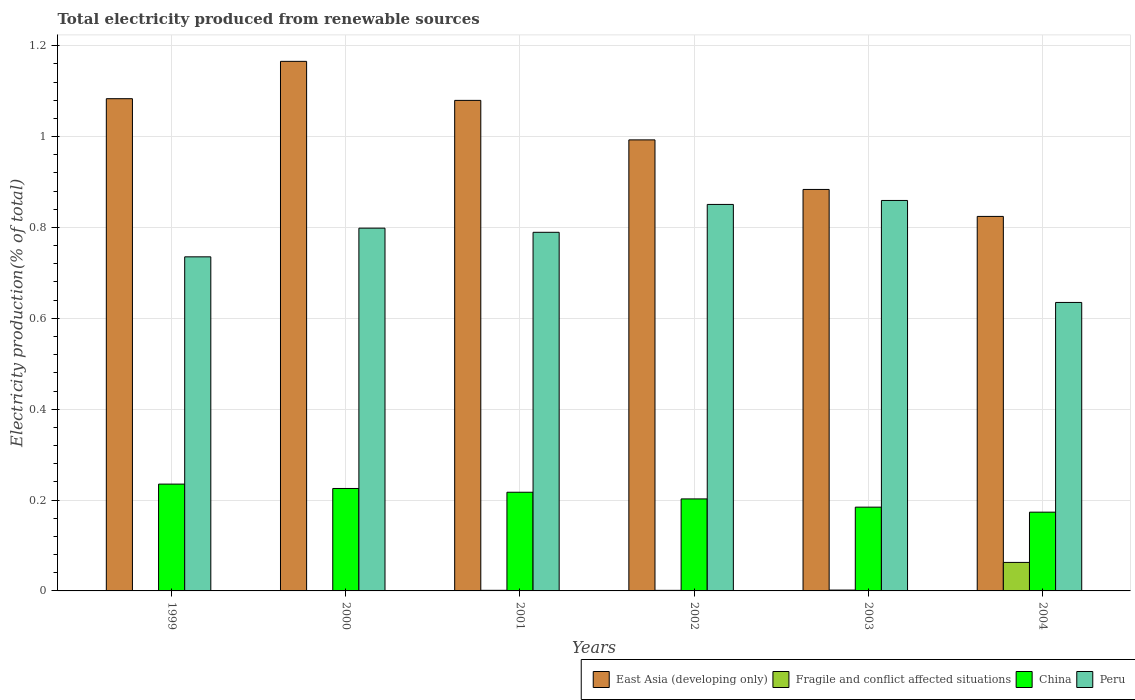Are the number of bars per tick equal to the number of legend labels?
Your response must be concise. Yes. Are the number of bars on each tick of the X-axis equal?
Your answer should be compact. Yes. How many bars are there on the 1st tick from the left?
Offer a terse response. 4. How many bars are there on the 1st tick from the right?
Provide a short and direct response. 4. What is the label of the 3rd group of bars from the left?
Make the answer very short. 2001. What is the total electricity produced in East Asia (developing only) in 1999?
Provide a succinct answer. 1.08. Across all years, what is the maximum total electricity produced in East Asia (developing only)?
Offer a very short reply. 1.17. Across all years, what is the minimum total electricity produced in Fragile and conflict affected situations?
Provide a short and direct response. 0. In which year was the total electricity produced in China maximum?
Your answer should be very brief. 1999. In which year was the total electricity produced in East Asia (developing only) minimum?
Make the answer very short. 2004. What is the total total electricity produced in East Asia (developing only) in the graph?
Your response must be concise. 6.03. What is the difference between the total electricity produced in Peru in 2000 and that in 2002?
Your response must be concise. -0.05. What is the difference between the total electricity produced in East Asia (developing only) in 2003 and the total electricity produced in Peru in 2004?
Your answer should be compact. 0.25. What is the average total electricity produced in Peru per year?
Your answer should be very brief. 0.78. In the year 2000, what is the difference between the total electricity produced in Peru and total electricity produced in East Asia (developing only)?
Your response must be concise. -0.37. What is the ratio of the total electricity produced in Peru in 2000 to that in 2003?
Make the answer very short. 0.93. What is the difference between the highest and the second highest total electricity produced in Peru?
Keep it short and to the point. 0.01. What is the difference between the highest and the lowest total electricity produced in China?
Your answer should be very brief. 0.06. Is it the case that in every year, the sum of the total electricity produced in Peru and total electricity produced in Fragile and conflict affected situations is greater than the sum of total electricity produced in China and total electricity produced in East Asia (developing only)?
Your answer should be compact. No. What does the 2nd bar from the left in 2004 represents?
Provide a short and direct response. Fragile and conflict affected situations. What does the 3rd bar from the right in 2002 represents?
Your response must be concise. Fragile and conflict affected situations. Is it the case that in every year, the sum of the total electricity produced in China and total electricity produced in East Asia (developing only) is greater than the total electricity produced in Peru?
Provide a succinct answer. Yes. How many bars are there?
Your answer should be compact. 24. How many years are there in the graph?
Ensure brevity in your answer.  6. What is the difference between two consecutive major ticks on the Y-axis?
Your answer should be compact. 0.2. Are the values on the major ticks of Y-axis written in scientific E-notation?
Keep it short and to the point. No. Does the graph contain any zero values?
Provide a short and direct response. No. Does the graph contain grids?
Your response must be concise. Yes. Where does the legend appear in the graph?
Offer a terse response. Bottom right. How many legend labels are there?
Offer a terse response. 4. What is the title of the graph?
Your answer should be very brief. Total electricity produced from renewable sources. What is the Electricity production(% of total) of East Asia (developing only) in 1999?
Offer a terse response. 1.08. What is the Electricity production(% of total) of Fragile and conflict affected situations in 1999?
Your response must be concise. 0. What is the Electricity production(% of total) of China in 1999?
Give a very brief answer. 0.24. What is the Electricity production(% of total) of Peru in 1999?
Offer a very short reply. 0.74. What is the Electricity production(% of total) of East Asia (developing only) in 2000?
Offer a very short reply. 1.17. What is the Electricity production(% of total) of Fragile and conflict affected situations in 2000?
Offer a terse response. 0. What is the Electricity production(% of total) of China in 2000?
Ensure brevity in your answer.  0.23. What is the Electricity production(% of total) of Peru in 2000?
Make the answer very short. 0.8. What is the Electricity production(% of total) in East Asia (developing only) in 2001?
Make the answer very short. 1.08. What is the Electricity production(% of total) in Fragile and conflict affected situations in 2001?
Provide a short and direct response. 0. What is the Electricity production(% of total) in China in 2001?
Make the answer very short. 0.22. What is the Electricity production(% of total) of Peru in 2001?
Provide a short and direct response. 0.79. What is the Electricity production(% of total) in East Asia (developing only) in 2002?
Make the answer very short. 0.99. What is the Electricity production(% of total) in Fragile and conflict affected situations in 2002?
Provide a short and direct response. 0. What is the Electricity production(% of total) in China in 2002?
Offer a very short reply. 0.2. What is the Electricity production(% of total) in Peru in 2002?
Your answer should be very brief. 0.85. What is the Electricity production(% of total) in East Asia (developing only) in 2003?
Offer a very short reply. 0.88. What is the Electricity production(% of total) of Fragile and conflict affected situations in 2003?
Provide a short and direct response. 0. What is the Electricity production(% of total) in China in 2003?
Provide a succinct answer. 0.18. What is the Electricity production(% of total) of Peru in 2003?
Offer a very short reply. 0.86. What is the Electricity production(% of total) of East Asia (developing only) in 2004?
Give a very brief answer. 0.82. What is the Electricity production(% of total) of Fragile and conflict affected situations in 2004?
Provide a short and direct response. 0.06. What is the Electricity production(% of total) in China in 2004?
Your answer should be compact. 0.17. What is the Electricity production(% of total) of Peru in 2004?
Your response must be concise. 0.63. Across all years, what is the maximum Electricity production(% of total) of East Asia (developing only)?
Your answer should be compact. 1.17. Across all years, what is the maximum Electricity production(% of total) of Fragile and conflict affected situations?
Keep it short and to the point. 0.06. Across all years, what is the maximum Electricity production(% of total) in China?
Give a very brief answer. 0.24. Across all years, what is the maximum Electricity production(% of total) of Peru?
Your answer should be compact. 0.86. Across all years, what is the minimum Electricity production(% of total) in East Asia (developing only)?
Make the answer very short. 0.82. Across all years, what is the minimum Electricity production(% of total) in Fragile and conflict affected situations?
Offer a terse response. 0. Across all years, what is the minimum Electricity production(% of total) in China?
Give a very brief answer. 0.17. Across all years, what is the minimum Electricity production(% of total) of Peru?
Provide a succinct answer. 0.63. What is the total Electricity production(% of total) in East Asia (developing only) in the graph?
Provide a short and direct response. 6.03. What is the total Electricity production(% of total) of Fragile and conflict affected situations in the graph?
Keep it short and to the point. 0.07. What is the total Electricity production(% of total) of China in the graph?
Provide a succinct answer. 1.24. What is the total Electricity production(% of total) of Peru in the graph?
Your answer should be compact. 4.67. What is the difference between the Electricity production(% of total) of East Asia (developing only) in 1999 and that in 2000?
Your answer should be compact. -0.08. What is the difference between the Electricity production(% of total) in Fragile and conflict affected situations in 1999 and that in 2000?
Your answer should be very brief. 0. What is the difference between the Electricity production(% of total) in China in 1999 and that in 2000?
Your answer should be compact. 0.01. What is the difference between the Electricity production(% of total) in Peru in 1999 and that in 2000?
Provide a short and direct response. -0.06. What is the difference between the Electricity production(% of total) of East Asia (developing only) in 1999 and that in 2001?
Make the answer very short. 0. What is the difference between the Electricity production(% of total) of Fragile and conflict affected situations in 1999 and that in 2001?
Your answer should be compact. -0. What is the difference between the Electricity production(% of total) of China in 1999 and that in 2001?
Keep it short and to the point. 0.02. What is the difference between the Electricity production(% of total) in Peru in 1999 and that in 2001?
Your response must be concise. -0.05. What is the difference between the Electricity production(% of total) in East Asia (developing only) in 1999 and that in 2002?
Give a very brief answer. 0.09. What is the difference between the Electricity production(% of total) of Fragile and conflict affected situations in 1999 and that in 2002?
Provide a succinct answer. -0. What is the difference between the Electricity production(% of total) of China in 1999 and that in 2002?
Provide a short and direct response. 0.03. What is the difference between the Electricity production(% of total) of Peru in 1999 and that in 2002?
Keep it short and to the point. -0.12. What is the difference between the Electricity production(% of total) of East Asia (developing only) in 1999 and that in 2003?
Your answer should be compact. 0.2. What is the difference between the Electricity production(% of total) of Fragile and conflict affected situations in 1999 and that in 2003?
Your answer should be very brief. -0. What is the difference between the Electricity production(% of total) of China in 1999 and that in 2003?
Keep it short and to the point. 0.05. What is the difference between the Electricity production(% of total) in Peru in 1999 and that in 2003?
Ensure brevity in your answer.  -0.12. What is the difference between the Electricity production(% of total) of East Asia (developing only) in 1999 and that in 2004?
Make the answer very short. 0.26. What is the difference between the Electricity production(% of total) in Fragile and conflict affected situations in 1999 and that in 2004?
Provide a short and direct response. -0.06. What is the difference between the Electricity production(% of total) of China in 1999 and that in 2004?
Keep it short and to the point. 0.06. What is the difference between the Electricity production(% of total) in Peru in 1999 and that in 2004?
Provide a short and direct response. 0.1. What is the difference between the Electricity production(% of total) in East Asia (developing only) in 2000 and that in 2001?
Offer a terse response. 0.09. What is the difference between the Electricity production(% of total) in Fragile and conflict affected situations in 2000 and that in 2001?
Provide a succinct answer. -0. What is the difference between the Electricity production(% of total) of China in 2000 and that in 2001?
Make the answer very short. 0.01. What is the difference between the Electricity production(% of total) of Peru in 2000 and that in 2001?
Give a very brief answer. 0.01. What is the difference between the Electricity production(% of total) of East Asia (developing only) in 2000 and that in 2002?
Offer a very short reply. 0.17. What is the difference between the Electricity production(% of total) in Fragile and conflict affected situations in 2000 and that in 2002?
Your response must be concise. -0. What is the difference between the Electricity production(% of total) of China in 2000 and that in 2002?
Offer a terse response. 0.02. What is the difference between the Electricity production(% of total) in Peru in 2000 and that in 2002?
Your answer should be compact. -0.05. What is the difference between the Electricity production(% of total) of East Asia (developing only) in 2000 and that in 2003?
Your answer should be very brief. 0.28. What is the difference between the Electricity production(% of total) of Fragile and conflict affected situations in 2000 and that in 2003?
Give a very brief answer. -0. What is the difference between the Electricity production(% of total) in China in 2000 and that in 2003?
Ensure brevity in your answer.  0.04. What is the difference between the Electricity production(% of total) in Peru in 2000 and that in 2003?
Your answer should be compact. -0.06. What is the difference between the Electricity production(% of total) in East Asia (developing only) in 2000 and that in 2004?
Ensure brevity in your answer.  0.34. What is the difference between the Electricity production(% of total) of Fragile and conflict affected situations in 2000 and that in 2004?
Provide a short and direct response. -0.06. What is the difference between the Electricity production(% of total) in China in 2000 and that in 2004?
Give a very brief answer. 0.05. What is the difference between the Electricity production(% of total) of Peru in 2000 and that in 2004?
Offer a very short reply. 0.16. What is the difference between the Electricity production(% of total) in East Asia (developing only) in 2001 and that in 2002?
Ensure brevity in your answer.  0.09. What is the difference between the Electricity production(% of total) of Fragile and conflict affected situations in 2001 and that in 2002?
Your answer should be compact. 0. What is the difference between the Electricity production(% of total) of China in 2001 and that in 2002?
Offer a terse response. 0.01. What is the difference between the Electricity production(% of total) of Peru in 2001 and that in 2002?
Provide a short and direct response. -0.06. What is the difference between the Electricity production(% of total) in East Asia (developing only) in 2001 and that in 2003?
Offer a very short reply. 0.2. What is the difference between the Electricity production(% of total) of Fragile and conflict affected situations in 2001 and that in 2003?
Your answer should be compact. -0. What is the difference between the Electricity production(% of total) of China in 2001 and that in 2003?
Keep it short and to the point. 0.03. What is the difference between the Electricity production(% of total) of Peru in 2001 and that in 2003?
Your answer should be compact. -0.07. What is the difference between the Electricity production(% of total) in East Asia (developing only) in 2001 and that in 2004?
Provide a succinct answer. 0.26. What is the difference between the Electricity production(% of total) in Fragile and conflict affected situations in 2001 and that in 2004?
Keep it short and to the point. -0.06. What is the difference between the Electricity production(% of total) in China in 2001 and that in 2004?
Offer a very short reply. 0.04. What is the difference between the Electricity production(% of total) in Peru in 2001 and that in 2004?
Ensure brevity in your answer.  0.15. What is the difference between the Electricity production(% of total) in East Asia (developing only) in 2002 and that in 2003?
Make the answer very short. 0.11. What is the difference between the Electricity production(% of total) in Fragile and conflict affected situations in 2002 and that in 2003?
Provide a succinct answer. -0. What is the difference between the Electricity production(% of total) in China in 2002 and that in 2003?
Provide a succinct answer. 0.02. What is the difference between the Electricity production(% of total) in Peru in 2002 and that in 2003?
Give a very brief answer. -0.01. What is the difference between the Electricity production(% of total) in East Asia (developing only) in 2002 and that in 2004?
Keep it short and to the point. 0.17. What is the difference between the Electricity production(% of total) of Fragile and conflict affected situations in 2002 and that in 2004?
Your answer should be very brief. -0.06. What is the difference between the Electricity production(% of total) of China in 2002 and that in 2004?
Give a very brief answer. 0.03. What is the difference between the Electricity production(% of total) of Peru in 2002 and that in 2004?
Offer a very short reply. 0.22. What is the difference between the Electricity production(% of total) of East Asia (developing only) in 2003 and that in 2004?
Provide a succinct answer. 0.06. What is the difference between the Electricity production(% of total) of Fragile and conflict affected situations in 2003 and that in 2004?
Offer a very short reply. -0.06. What is the difference between the Electricity production(% of total) of China in 2003 and that in 2004?
Give a very brief answer. 0.01. What is the difference between the Electricity production(% of total) of Peru in 2003 and that in 2004?
Provide a succinct answer. 0.22. What is the difference between the Electricity production(% of total) in East Asia (developing only) in 1999 and the Electricity production(% of total) in Fragile and conflict affected situations in 2000?
Provide a succinct answer. 1.08. What is the difference between the Electricity production(% of total) of East Asia (developing only) in 1999 and the Electricity production(% of total) of China in 2000?
Your answer should be compact. 0.86. What is the difference between the Electricity production(% of total) of East Asia (developing only) in 1999 and the Electricity production(% of total) of Peru in 2000?
Ensure brevity in your answer.  0.28. What is the difference between the Electricity production(% of total) in Fragile and conflict affected situations in 1999 and the Electricity production(% of total) in China in 2000?
Offer a terse response. -0.22. What is the difference between the Electricity production(% of total) of Fragile and conflict affected situations in 1999 and the Electricity production(% of total) of Peru in 2000?
Make the answer very short. -0.8. What is the difference between the Electricity production(% of total) of China in 1999 and the Electricity production(% of total) of Peru in 2000?
Make the answer very short. -0.56. What is the difference between the Electricity production(% of total) of East Asia (developing only) in 1999 and the Electricity production(% of total) of Fragile and conflict affected situations in 2001?
Provide a short and direct response. 1.08. What is the difference between the Electricity production(% of total) of East Asia (developing only) in 1999 and the Electricity production(% of total) of China in 2001?
Provide a succinct answer. 0.87. What is the difference between the Electricity production(% of total) in East Asia (developing only) in 1999 and the Electricity production(% of total) in Peru in 2001?
Give a very brief answer. 0.29. What is the difference between the Electricity production(% of total) in Fragile and conflict affected situations in 1999 and the Electricity production(% of total) in China in 2001?
Provide a short and direct response. -0.22. What is the difference between the Electricity production(% of total) in Fragile and conflict affected situations in 1999 and the Electricity production(% of total) in Peru in 2001?
Your answer should be compact. -0.79. What is the difference between the Electricity production(% of total) of China in 1999 and the Electricity production(% of total) of Peru in 2001?
Keep it short and to the point. -0.55. What is the difference between the Electricity production(% of total) in East Asia (developing only) in 1999 and the Electricity production(% of total) in Fragile and conflict affected situations in 2002?
Ensure brevity in your answer.  1.08. What is the difference between the Electricity production(% of total) of East Asia (developing only) in 1999 and the Electricity production(% of total) of China in 2002?
Make the answer very short. 0.88. What is the difference between the Electricity production(% of total) of East Asia (developing only) in 1999 and the Electricity production(% of total) of Peru in 2002?
Offer a terse response. 0.23. What is the difference between the Electricity production(% of total) in Fragile and conflict affected situations in 1999 and the Electricity production(% of total) in China in 2002?
Offer a terse response. -0.2. What is the difference between the Electricity production(% of total) of Fragile and conflict affected situations in 1999 and the Electricity production(% of total) of Peru in 2002?
Ensure brevity in your answer.  -0.85. What is the difference between the Electricity production(% of total) in China in 1999 and the Electricity production(% of total) in Peru in 2002?
Provide a succinct answer. -0.62. What is the difference between the Electricity production(% of total) of East Asia (developing only) in 1999 and the Electricity production(% of total) of Fragile and conflict affected situations in 2003?
Your answer should be compact. 1.08. What is the difference between the Electricity production(% of total) in East Asia (developing only) in 1999 and the Electricity production(% of total) in China in 2003?
Keep it short and to the point. 0.9. What is the difference between the Electricity production(% of total) of East Asia (developing only) in 1999 and the Electricity production(% of total) of Peru in 2003?
Give a very brief answer. 0.22. What is the difference between the Electricity production(% of total) of Fragile and conflict affected situations in 1999 and the Electricity production(% of total) of China in 2003?
Your response must be concise. -0.18. What is the difference between the Electricity production(% of total) of Fragile and conflict affected situations in 1999 and the Electricity production(% of total) of Peru in 2003?
Ensure brevity in your answer.  -0.86. What is the difference between the Electricity production(% of total) in China in 1999 and the Electricity production(% of total) in Peru in 2003?
Offer a terse response. -0.62. What is the difference between the Electricity production(% of total) in East Asia (developing only) in 1999 and the Electricity production(% of total) in Fragile and conflict affected situations in 2004?
Offer a terse response. 1.02. What is the difference between the Electricity production(% of total) in East Asia (developing only) in 1999 and the Electricity production(% of total) in China in 2004?
Your answer should be very brief. 0.91. What is the difference between the Electricity production(% of total) in East Asia (developing only) in 1999 and the Electricity production(% of total) in Peru in 2004?
Provide a succinct answer. 0.45. What is the difference between the Electricity production(% of total) in Fragile and conflict affected situations in 1999 and the Electricity production(% of total) in China in 2004?
Your answer should be very brief. -0.17. What is the difference between the Electricity production(% of total) of Fragile and conflict affected situations in 1999 and the Electricity production(% of total) of Peru in 2004?
Make the answer very short. -0.63. What is the difference between the Electricity production(% of total) of China in 1999 and the Electricity production(% of total) of Peru in 2004?
Offer a terse response. -0.4. What is the difference between the Electricity production(% of total) of East Asia (developing only) in 2000 and the Electricity production(% of total) of Fragile and conflict affected situations in 2001?
Provide a succinct answer. 1.16. What is the difference between the Electricity production(% of total) in East Asia (developing only) in 2000 and the Electricity production(% of total) in China in 2001?
Offer a very short reply. 0.95. What is the difference between the Electricity production(% of total) in East Asia (developing only) in 2000 and the Electricity production(% of total) in Peru in 2001?
Provide a succinct answer. 0.38. What is the difference between the Electricity production(% of total) of Fragile and conflict affected situations in 2000 and the Electricity production(% of total) of China in 2001?
Keep it short and to the point. -0.22. What is the difference between the Electricity production(% of total) of Fragile and conflict affected situations in 2000 and the Electricity production(% of total) of Peru in 2001?
Provide a succinct answer. -0.79. What is the difference between the Electricity production(% of total) of China in 2000 and the Electricity production(% of total) of Peru in 2001?
Your answer should be very brief. -0.56. What is the difference between the Electricity production(% of total) in East Asia (developing only) in 2000 and the Electricity production(% of total) in Fragile and conflict affected situations in 2002?
Offer a terse response. 1.16. What is the difference between the Electricity production(% of total) of East Asia (developing only) in 2000 and the Electricity production(% of total) of China in 2002?
Provide a short and direct response. 0.96. What is the difference between the Electricity production(% of total) of East Asia (developing only) in 2000 and the Electricity production(% of total) of Peru in 2002?
Your answer should be compact. 0.31. What is the difference between the Electricity production(% of total) of Fragile and conflict affected situations in 2000 and the Electricity production(% of total) of China in 2002?
Your answer should be compact. -0.2. What is the difference between the Electricity production(% of total) of Fragile and conflict affected situations in 2000 and the Electricity production(% of total) of Peru in 2002?
Provide a short and direct response. -0.85. What is the difference between the Electricity production(% of total) of China in 2000 and the Electricity production(% of total) of Peru in 2002?
Offer a very short reply. -0.63. What is the difference between the Electricity production(% of total) in East Asia (developing only) in 2000 and the Electricity production(% of total) in Fragile and conflict affected situations in 2003?
Make the answer very short. 1.16. What is the difference between the Electricity production(% of total) of East Asia (developing only) in 2000 and the Electricity production(% of total) of China in 2003?
Offer a terse response. 0.98. What is the difference between the Electricity production(% of total) in East Asia (developing only) in 2000 and the Electricity production(% of total) in Peru in 2003?
Give a very brief answer. 0.31. What is the difference between the Electricity production(% of total) of Fragile and conflict affected situations in 2000 and the Electricity production(% of total) of China in 2003?
Ensure brevity in your answer.  -0.18. What is the difference between the Electricity production(% of total) in Fragile and conflict affected situations in 2000 and the Electricity production(% of total) in Peru in 2003?
Make the answer very short. -0.86. What is the difference between the Electricity production(% of total) in China in 2000 and the Electricity production(% of total) in Peru in 2003?
Ensure brevity in your answer.  -0.63. What is the difference between the Electricity production(% of total) in East Asia (developing only) in 2000 and the Electricity production(% of total) in Fragile and conflict affected situations in 2004?
Offer a terse response. 1.1. What is the difference between the Electricity production(% of total) in East Asia (developing only) in 2000 and the Electricity production(% of total) in Peru in 2004?
Ensure brevity in your answer.  0.53. What is the difference between the Electricity production(% of total) of Fragile and conflict affected situations in 2000 and the Electricity production(% of total) of China in 2004?
Make the answer very short. -0.17. What is the difference between the Electricity production(% of total) in Fragile and conflict affected situations in 2000 and the Electricity production(% of total) in Peru in 2004?
Offer a terse response. -0.63. What is the difference between the Electricity production(% of total) of China in 2000 and the Electricity production(% of total) of Peru in 2004?
Offer a very short reply. -0.41. What is the difference between the Electricity production(% of total) in East Asia (developing only) in 2001 and the Electricity production(% of total) in Fragile and conflict affected situations in 2002?
Your answer should be compact. 1.08. What is the difference between the Electricity production(% of total) in East Asia (developing only) in 2001 and the Electricity production(% of total) in China in 2002?
Your answer should be very brief. 0.88. What is the difference between the Electricity production(% of total) in East Asia (developing only) in 2001 and the Electricity production(% of total) in Peru in 2002?
Your answer should be compact. 0.23. What is the difference between the Electricity production(% of total) of Fragile and conflict affected situations in 2001 and the Electricity production(% of total) of China in 2002?
Your response must be concise. -0.2. What is the difference between the Electricity production(% of total) in Fragile and conflict affected situations in 2001 and the Electricity production(% of total) in Peru in 2002?
Ensure brevity in your answer.  -0.85. What is the difference between the Electricity production(% of total) of China in 2001 and the Electricity production(% of total) of Peru in 2002?
Provide a short and direct response. -0.63. What is the difference between the Electricity production(% of total) in East Asia (developing only) in 2001 and the Electricity production(% of total) in Fragile and conflict affected situations in 2003?
Ensure brevity in your answer.  1.08. What is the difference between the Electricity production(% of total) of East Asia (developing only) in 2001 and the Electricity production(% of total) of China in 2003?
Make the answer very short. 0.9. What is the difference between the Electricity production(% of total) in East Asia (developing only) in 2001 and the Electricity production(% of total) in Peru in 2003?
Give a very brief answer. 0.22. What is the difference between the Electricity production(% of total) in Fragile and conflict affected situations in 2001 and the Electricity production(% of total) in China in 2003?
Your answer should be very brief. -0.18. What is the difference between the Electricity production(% of total) in Fragile and conflict affected situations in 2001 and the Electricity production(% of total) in Peru in 2003?
Make the answer very short. -0.86. What is the difference between the Electricity production(% of total) of China in 2001 and the Electricity production(% of total) of Peru in 2003?
Give a very brief answer. -0.64. What is the difference between the Electricity production(% of total) in East Asia (developing only) in 2001 and the Electricity production(% of total) in Fragile and conflict affected situations in 2004?
Offer a terse response. 1.02. What is the difference between the Electricity production(% of total) of East Asia (developing only) in 2001 and the Electricity production(% of total) of China in 2004?
Give a very brief answer. 0.91. What is the difference between the Electricity production(% of total) of East Asia (developing only) in 2001 and the Electricity production(% of total) of Peru in 2004?
Give a very brief answer. 0.44. What is the difference between the Electricity production(% of total) in Fragile and conflict affected situations in 2001 and the Electricity production(% of total) in China in 2004?
Provide a succinct answer. -0.17. What is the difference between the Electricity production(% of total) in Fragile and conflict affected situations in 2001 and the Electricity production(% of total) in Peru in 2004?
Offer a very short reply. -0.63. What is the difference between the Electricity production(% of total) in China in 2001 and the Electricity production(% of total) in Peru in 2004?
Offer a very short reply. -0.42. What is the difference between the Electricity production(% of total) of East Asia (developing only) in 2002 and the Electricity production(% of total) of China in 2003?
Offer a terse response. 0.81. What is the difference between the Electricity production(% of total) of East Asia (developing only) in 2002 and the Electricity production(% of total) of Peru in 2003?
Your answer should be compact. 0.13. What is the difference between the Electricity production(% of total) of Fragile and conflict affected situations in 2002 and the Electricity production(% of total) of China in 2003?
Offer a very short reply. -0.18. What is the difference between the Electricity production(% of total) in Fragile and conflict affected situations in 2002 and the Electricity production(% of total) in Peru in 2003?
Provide a succinct answer. -0.86. What is the difference between the Electricity production(% of total) in China in 2002 and the Electricity production(% of total) in Peru in 2003?
Provide a succinct answer. -0.66. What is the difference between the Electricity production(% of total) in East Asia (developing only) in 2002 and the Electricity production(% of total) in Fragile and conflict affected situations in 2004?
Your answer should be very brief. 0.93. What is the difference between the Electricity production(% of total) of East Asia (developing only) in 2002 and the Electricity production(% of total) of China in 2004?
Ensure brevity in your answer.  0.82. What is the difference between the Electricity production(% of total) in East Asia (developing only) in 2002 and the Electricity production(% of total) in Peru in 2004?
Give a very brief answer. 0.36. What is the difference between the Electricity production(% of total) in Fragile and conflict affected situations in 2002 and the Electricity production(% of total) in China in 2004?
Keep it short and to the point. -0.17. What is the difference between the Electricity production(% of total) of Fragile and conflict affected situations in 2002 and the Electricity production(% of total) of Peru in 2004?
Offer a very short reply. -0.63. What is the difference between the Electricity production(% of total) of China in 2002 and the Electricity production(% of total) of Peru in 2004?
Offer a very short reply. -0.43. What is the difference between the Electricity production(% of total) in East Asia (developing only) in 2003 and the Electricity production(% of total) in Fragile and conflict affected situations in 2004?
Provide a succinct answer. 0.82. What is the difference between the Electricity production(% of total) in East Asia (developing only) in 2003 and the Electricity production(% of total) in China in 2004?
Offer a very short reply. 0.71. What is the difference between the Electricity production(% of total) in East Asia (developing only) in 2003 and the Electricity production(% of total) in Peru in 2004?
Ensure brevity in your answer.  0.25. What is the difference between the Electricity production(% of total) in Fragile and conflict affected situations in 2003 and the Electricity production(% of total) in China in 2004?
Keep it short and to the point. -0.17. What is the difference between the Electricity production(% of total) in Fragile and conflict affected situations in 2003 and the Electricity production(% of total) in Peru in 2004?
Offer a very short reply. -0.63. What is the difference between the Electricity production(% of total) in China in 2003 and the Electricity production(% of total) in Peru in 2004?
Offer a very short reply. -0.45. What is the average Electricity production(% of total) in East Asia (developing only) per year?
Provide a succinct answer. 1. What is the average Electricity production(% of total) of Fragile and conflict affected situations per year?
Offer a terse response. 0.01. What is the average Electricity production(% of total) in China per year?
Your answer should be compact. 0.21. What is the average Electricity production(% of total) in Peru per year?
Your answer should be compact. 0.78. In the year 1999, what is the difference between the Electricity production(% of total) of East Asia (developing only) and Electricity production(% of total) of Fragile and conflict affected situations?
Provide a succinct answer. 1.08. In the year 1999, what is the difference between the Electricity production(% of total) in East Asia (developing only) and Electricity production(% of total) in China?
Your response must be concise. 0.85. In the year 1999, what is the difference between the Electricity production(% of total) in East Asia (developing only) and Electricity production(% of total) in Peru?
Offer a very short reply. 0.35. In the year 1999, what is the difference between the Electricity production(% of total) of Fragile and conflict affected situations and Electricity production(% of total) of China?
Make the answer very short. -0.23. In the year 1999, what is the difference between the Electricity production(% of total) in Fragile and conflict affected situations and Electricity production(% of total) in Peru?
Keep it short and to the point. -0.73. In the year 1999, what is the difference between the Electricity production(% of total) in China and Electricity production(% of total) in Peru?
Provide a succinct answer. -0.5. In the year 2000, what is the difference between the Electricity production(% of total) in East Asia (developing only) and Electricity production(% of total) in Fragile and conflict affected situations?
Make the answer very short. 1.16. In the year 2000, what is the difference between the Electricity production(% of total) in East Asia (developing only) and Electricity production(% of total) in China?
Offer a terse response. 0.94. In the year 2000, what is the difference between the Electricity production(% of total) of East Asia (developing only) and Electricity production(% of total) of Peru?
Offer a very short reply. 0.37. In the year 2000, what is the difference between the Electricity production(% of total) in Fragile and conflict affected situations and Electricity production(% of total) in China?
Your answer should be very brief. -0.22. In the year 2000, what is the difference between the Electricity production(% of total) in Fragile and conflict affected situations and Electricity production(% of total) in Peru?
Make the answer very short. -0.8. In the year 2000, what is the difference between the Electricity production(% of total) in China and Electricity production(% of total) in Peru?
Your answer should be very brief. -0.57. In the year 2001, what is the difference between the Electricity production(% of total) of East Asia (developing only) and Electricity production(% of total) of Fragile and conflict affected situations?
Keep it short and to the point. 1.08. In the year 2001, what is the difference between the Electricity production(% of total) of East Asia (developing only) and Electricity production(% of total) of China?
Provide a short and direct response. 0.86. In the year 2001, what is the difference between the Electricity production(% of total) of East Asia (developing only) and Electricity production(% of total) of Peru?
Offer a very short reply. 0.29. In the year 2001, what is the difference between the Electricity production(% of total) of Fragile and conflict affected situations and Electricity production(% of total) of China?
Give a very brief answer. -0.22. In the year 2001, what is the difference between the Electricity production(% of total) in Fragile and conflict affected situations and Electricity production(% of total) in Peru?
Provide a short and direct response. -0.79. In the year 2001, what is the difference between the Electricity production(% of total) in China and Electricity production(% of total) in Peru?
Provide a succinct answer. -0.57. In the year 2002, what is the difference between the Electricity production(% of total) in East Asia (developing only) and Electricity production(% of total) in China?
Provide a succinct answer. 0.79. In the year 2002, what is the difference between the Electricity production(% of total) of East Asia (developing only) and Electricity production(% of total) of Peru?
Your answer should be compact. 0.14. In the year 2002, what is the difference between the Electricity production(% of total) of Fragile and conflict affected situations and Electricity production(% of total) of China?
Make the answer very short. -0.2. In the year 2002, what is the difference between the Electricity production(% of total) of Fragile and conflict affected situations and Electricity production(% of total) of Peru?
Offer a terse response. -0.85. In the year 2002, what is the difference between the Electricity production(% of total) of China and Electricity production(% of total) of Peru?
Keep it short and to the point. -0.65. In the year 2003, what is the difference between the Electricity production(% of total) of East Asia (developing only) and Electricity production(% of total) of Fragile and conflict affected situations?
Provide a succinct answer. 0.88. In the year 2003, what is the difference between the Electricity production(% of total) of East Asia (developing only) and Electricity production(% of total) of China?
Your response must be concise. 0.7. In the year 2003, what is the difference between the Electricity production(% of total) in East Asia (developing only) and Electricity production(% of total) in Peru?
Your answer should be very brief. 0.02. In the year 2003, what is the difference between the Electricity production(% of total) in Fragile and conflict affected situations and Electricity production(% of total) in China?
Offer a very short reply. -0.18. In the year 2003, what is the difference between the Electricity production(% of total) of Fragile and conflict affected situations and Electricity production(% of total) of Peru?
Provide a succinct answer. -0.86. In the year 2003, what is the difference between the Electricity production(% of total) in China and Electricity production(% of total) in Peru?
Your answer should be very brief. -0.68. In the year 2004, what is the difference between the Electricity production(% of total) in East Asia (developing only) and Electricity production(% of total) in Fragile and conflict affected situations?
Your answer should be compact. 0.76. In the year 2004, what is the difference between the Electricity production(% of total) of East Asia (developing only) and Electricity production(% of total) of China?
Give a very brief answer. 0.65. In the year 2004, what is the difference between the Electricity production(% of total) in East Asia (developing only) and Electricity production(% of total) in Peru?
Your answer should be very brief. 0.19. In the year 2004, what is the difference between the Electricity production(% of total) in Fragile and conflict affected situations and Electricity production(% of total) in China?
Your response must be concise. -0.11. In the year 2004, what is the difference between the Electricity production(% of total) in Fragile and conflict affected situations and Electricity production(% of total) in Peru?
Offer a very short reply. -0.57. In the year 2004, what is the difference between the Electricity production(% of total) in China and Electricity production(% of total) in Peru?
Offer a terse response. -0.46. What is the ratio of the Electricity production(% of total) in East Asia (developing only) in 1999 to that in 2000?
Make the answer very short. 0.93. What is the ratio of the Electricity production(% of total) in Fragile and conflict affected situations in 1999 to that in 2000?
Your answer should be compact. 1.04. What is the ratio of the Electricity production(% of total) of China in 1999 to that in 2000?
Offer a very short reply. 1.04. What is the ratio of the Electricity production(% of total) of Peru in 1999 to that in 2000?
Make the answer very short. 0.92. What is the ratio of the Electricity production(% of total) of East Asia (developing only) in 1999 to that in 2001?
Provide a succinct answer. 1. What is the ratio of the Electricity production(% of total) in Fragile and conflict affected situations in 1999 to that in 2001?
Give a very brief answer. 0.54. What is the ratio of the Electricity production(% of total) of China in 1999 to that in 2001?
Give a very brief answer. 1.08. What is the ratio of the Electricity production(% of total) of Peru in 1999 to that in 2001?
Offer a terse response. 0.93. What is the ratio of the Electricity production(% of total) in East Asia (developing only) in 1999 to that in 2002?
Your response must be concise. 1.09. What is the ratio of the Electricity production(% of total) in Fragile and conflict affected situations in 1999 to that in 2002?
Offer a very short reply. 0.58. What is the ratio of the Electricity production(% of total) in China in 1999 to that in 2002?
Keep it short and to the point. 1.16. What is the ratio of the Electricity production(% of total) in Peru in 1999 to that in 2002?
Your answer should be compact. 0.86. What is the ratio of the Electricity production(% of total) in East Asia (developing only) in 1999 to that in 2003?
Offer a very short reply. 1.23. What is the ratio of the Electricity production(% of total) in Fragile and conflict affected situations in 1999 to that in 2003?
Offer a terse response. 0.38. What is the ratio of the Electricity production(% of total) of China in 1999 to that in 2003?
Provide a succinct answer. 1.28. What is the ratio of the Electricity production(% of total) of Peru in 1999 to that in 2003?
Provide a short and direct response. 0.86. What is the ratio of the Electricity production(% of total) of East Asia (developing only) in 1999 to that in 2004?
Offer a terse response. 1.31. What is the ratio of the Electricity production(% of total) of Fragile and conflict affected situations in 1999 to that in 2004?
Provide a succinct answer. 0.01. What is the ratio of the Electricity production(% of total) in China in 1999 to that in 2004?
Your answer should be very brief. 1.36. What is the ratio of the Electricity production(% of total) in Peru in 1999 to that in 2004?
Your response must be concise. 1.16. What is the ratio of the Electricity production(% of total) in East Asia (developing only) in 2000 to that in 2001?
Your response must be concise. 1.08. What is the ratio of the Electricity production(% of total) in Fragile and conflict affected situations in 2000 to that in 2001?
Provide a succinct answer. 0.52. What is the ratio of the Electricity production(% of total) of China in 2000 to that in 2001?
Give a very brief answer. 1.04. What is the ratio of the Electricity production(% of total) in Peru in 2000 to that in 2001?
Your response must be concise. 1.01. What is the ratio of the Electricity production(% of total) of East Asia (developing only) in 2000 to that in 2002?
Offer a very short reply. 1.17. What is the ratio of the Electricity production(% of total) of Fragile and conflict affected situations in 2000 to that in 2002?
Give a very brief answer. 0.55. What is the ratio of the Electricity production(% of total) of China in 2000 to that in 2002?
Provide a succinct answer. 1.11. What is the ratio of the Electricity production(% of total) of Peru in 2000 to that in 2002?
Your answer should be compact. 0.94. What is the ratio of the Electricity production(% of total) of East Asia (developing only) in 2000 to that in 2003?
Give a very brief answer. 1.32. What is the ratio of the Electricity production(% of total) of Fragile and conflict affected situations in 2000 to that in 2003?
Offer a terse response. 0.37. What is the ratio of the Electricity production(% of total) in China in 2000 to that in 2003?
Keep it short and to the point. 1.22. What is the ratio of the Electricity production(% of total) in Peru in 2000 to that in 2003?
Your answer should be compact. 0.93. What is the ratio of the Electricity production(% of total) in East Asia (developing only) in 2000 to that in 2004?
Your answer should be compact. 1.41. What is the ratio of the Electricity production(% of total) in Fragile and conflict affected situations in 2000 to that in 2004?
Your answer should be compact. 0.01. What is the ratio of the Electricity production(% of total) in China in 2000 to that in 2004?
Provide a succinct answer. 1.3. What is the ratio of the Electricity production(% of total) of Peru in 2000 to that in 2004?
Offer a very short reply. 1.26. What is the ratio of the Electricity production(% of total) in East Asia (developing only) in 2001 to that in 2002?
Give a very brief answer. 1.09. What is the ratio of the Electricity production(% of total) in Fragile and conflict affected situations in 2001 to that in 2002?
Make the answer very short. 1.06. What is the ratio of the Electricity production(% of total) of China in 2001 to that in 2002?
Your answer should be compact. 1.07. What is the ratio of the Electricity production(% of total) in Peru in 2001 to that in 2002?
Your answer should be compact. 0.93. What is the ratio of the Electricity production(% of total) in East Asia (developing only) in 2001 to that in 2003?
Provide a short and direct response. 1.22. What is the ratio of the Electricity production(% of total) in Fragile and conflict affected situations in 2001 to that in 2003?
Your response must be concise. 0.71. What is the ratio of the Electricity production(% of total) of China in 2001 to that in 2003?
Keep it short and to the point. 1.18. What is the ratio of the Electricity production(% of total) in Peru in 2001 to that in 2003?
Ensure brevity in your answer.  0.92. What is the ratio of the Electricity production(% of total) of East Asia (developing only) in 2001 to that in 2004?
Keep it short and to the point. 1.31. What is the ratio of the Electricity production(% of total) of Fragile and conflict affected situations in 2001 to that in 2004?
Make the answer very short. 0.02. What is the ratio of the Electricity production(% of total) of China in 2001 to that in 2004?
Your answer should be very brief. 1.25. What is the ratio of the Electricity production(% of total) in Peru in 2001 to that in 2004?
Your answer should be very brief. 1.24. What is the ratio of the Electricity production(% of total) in East Asia (developing only) in 2002 to that in 2003?
Your answer should be compact. 1.12. What is the ratio of the Electricity production(% of total) in Fragile and conflict affected situations in 2002 to that in 2003?
Offer a very short reply. 0.67. What is the ratio of the Electricity production(% of total) in China in 2002 to that in 2003?
Keep it short and to the point. 1.1. What is the ratio of the Electricity production(% of total) in Peru in 2002 to that in 2003?
Your answer should be very brief. 0.99. What is the ratio of the Electricity production(% of total) of East Asia (developing only) in 2002 to that in 2004?
Offer a terse response. 1.2. What is the ratio of the Electricity production(% of total) in Fragile and conflict affected situations in 2002 to that in 2004?
Your answer should be compact. 0.02. What is the ratio of the Electricity production(% of total) in China in 2002 to that in 2004?
Make the answer very short. 1.17. What is the ratio of the Electricity production(% of total) of Peru in 2002 to that in 2004?
Keep it short and to the point. 1.34. What is the ratio of the Electricity production(% of total) of East Asia (developing only) in 2003 to that in 2004?
Offer a terse response. 1.07. What is the ratio of the Electricity production(% of total) of Fragile and conflict affected situations in 2003 to that in 2004?
Provide a succinct answer. 0.03. What is the ratio of the Electricity production(% of total) in China in 2003 to that in 2004?
Provide a short and direct response. 1.06. What is the ratio of the Electricity production(% of total) of Peru in 2003 to that in 2004?
Provide a succinct answer. 1.35. What is the difference between the highest and the second highest Electricity production(% of total) of East Asia (developing only)?
Provide a short and direct response. 0.08. What is the difference between the highest and the second highest Electricity production(% of total) of Fragile and conflict affected situations?
Ensure brevity in your answer.  0.06. What is the difference between the highest and the second highest Electricity production(% of total) in China?
Your response must be concise. 0.01. What is the difference between the highest and the second highest Electricity production(% of total) of Peru?
Your response must be concise. 0.01. What is the difference between the highest and the lowest Electricity production(% of total) of East Asia (developing only)?
Keep it short and to the point. 0.34. What is the difference between the highest and the lowest Electricity production(% of total) in Fragile and conflict affected situations?
Your answer should be compact. 0.06. What is the difference between the highest and the lowest Electricity production(% of total) in China?
Your response must be concise. 0.06. What is the difference between the highest and the lowest Electricity production(% of total) of Peru?
Offer a very short reply. 0.22. 